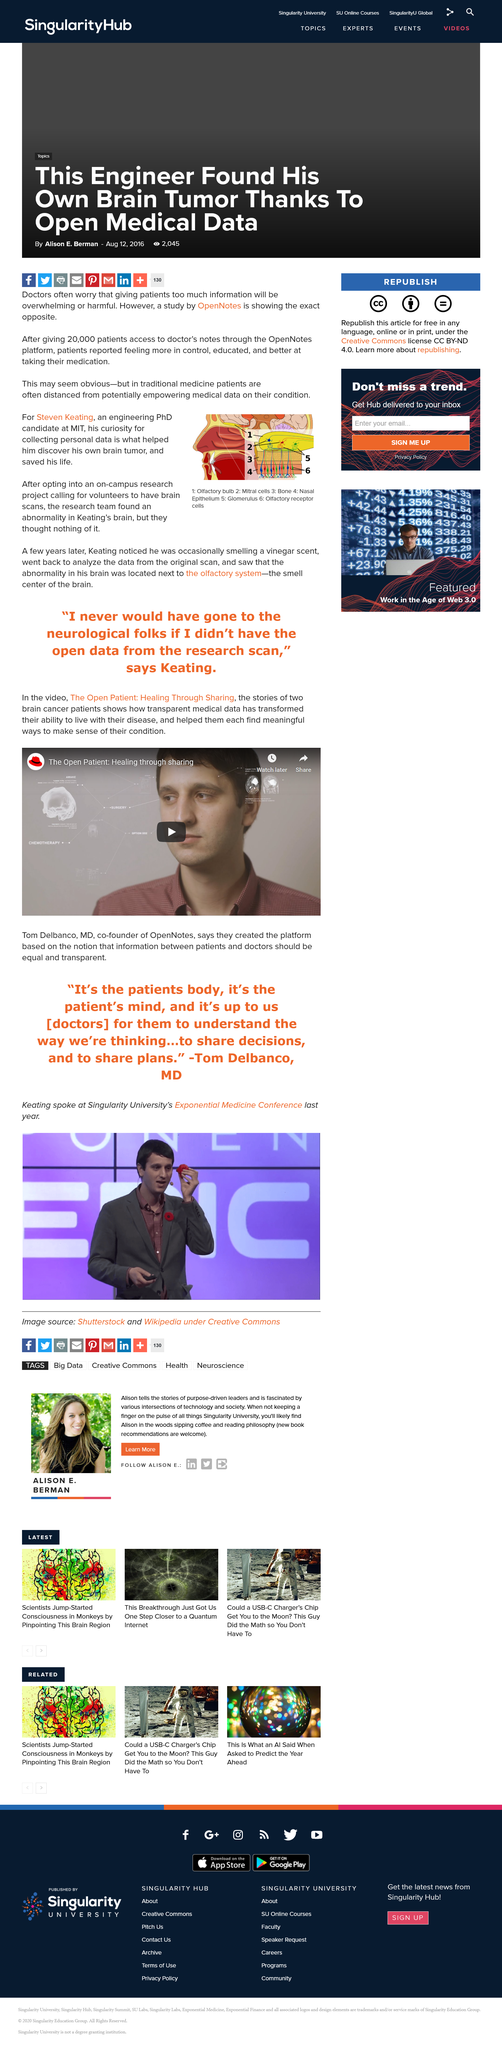Specify some key components in this picture. The on-campus research project called for volunteers to undergo brain scans as part of its efforts. Steven Keating was studying at MIT. The research team discovered an abnormality on Steve Keating's brain, and he discovered that it was a brain tumor. 